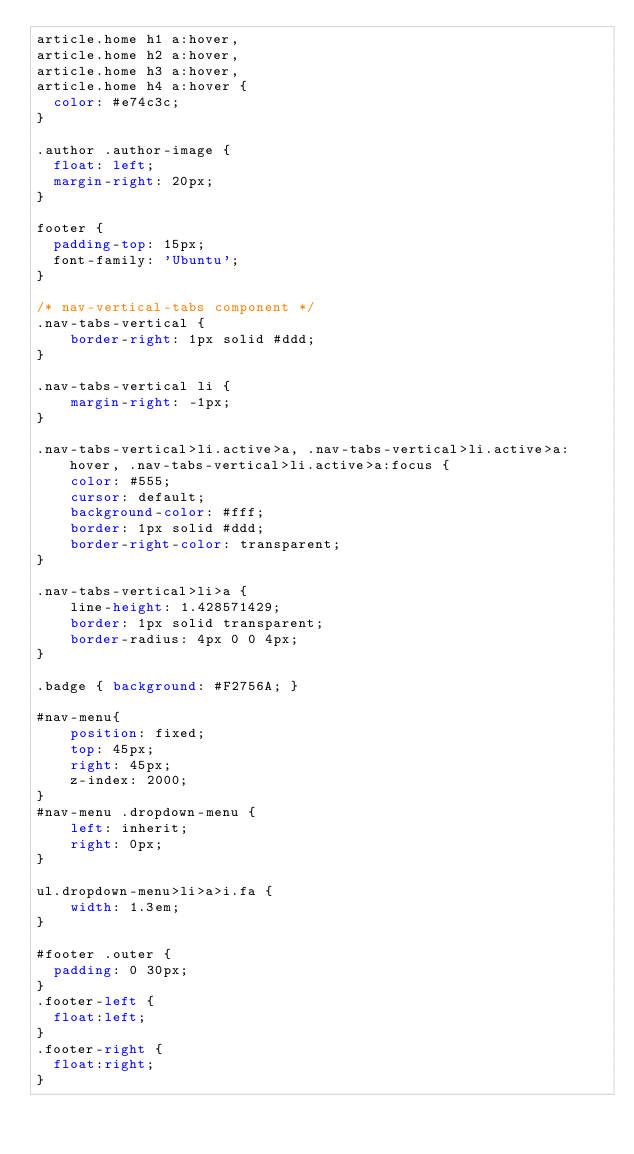<code> <loc_0><loc_0><loc_500><loc_500><_CSS_>article.home h1 a:hover,
article.home h2 a:hover,
article.home h3 a:hover,
article.home h4 a:hover {
	color: #e74c3c;
}

.author .author-image {
  float: left;
  margin-right: 20px;
}

footer {
	padding-top: 15px;
	font-family: 'Ubuntu';
}

/* nav-vertical-tabs component */
.nav-tabs-vertical {
    border-right: 1px solid #ddd;
}

.nav-tabs-vertical li {
    margin-right: -1px;
}

.nav-tabs-vertical>li.active>a, .nav-tabs-vertical>li.active>a:hover, .nav-tabs-vertical>li.active>a:focus {
    color: #555;
    cursor: default;
    background-color: #fff;
    border: 1px solid #ddd;
    border-right-color: transparent;
}

.nav-tabs-vertical>li>a {
    line-height: 1.428571429;
    border: 1px solid transparent;
    border-radius: 4px 0 0 4px;
}

.badge { background: #F2756A; }

#nav-menu{
    position: fixed;
    top: 45px;
    right: 45px;
    z-index: 2000;
}
#nav-menu .dropdown-menu {
    left: inherit;
    right: 0px;
}

ul.dropdown-menu>li>a>i.fa {
    width: 1.3em;
}

#footer .outer {
	padding: 0 30px;
}
.footer-left {
	float:left;
}
.footer-right {
	float:right;
}
</code> 